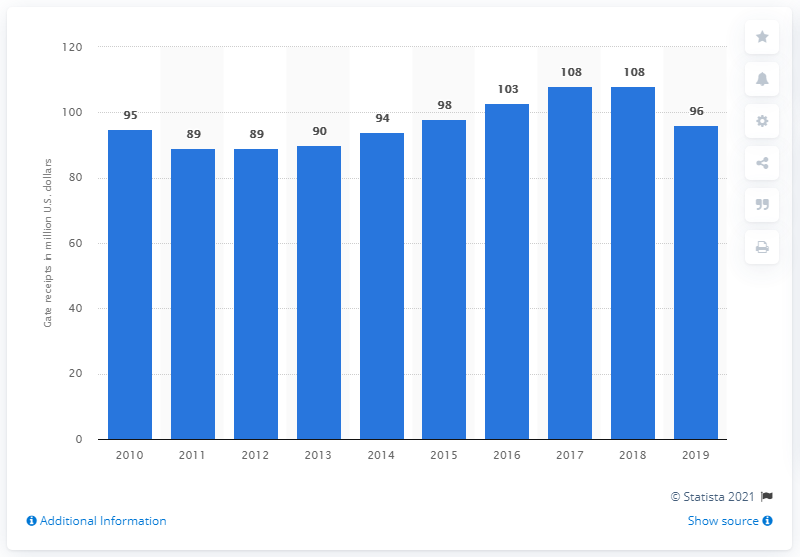List a handful of essential elements in this visual. The Dallas Cowboys' gate receipts for the 2019 season were $96 million. 